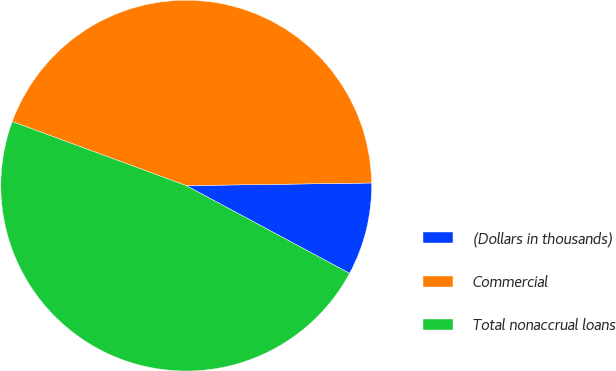Convert chart to OTSL. <chart><loc_0><loc_0><loc_500><loc_500><pie_chart><fcel>(Dollars in thousands)<fcel>Commercial<fcel>Total nonaccrual loans<nl><fcel>8.07%<fcel>44.16%<fcel>47.77%<nl></chart> 